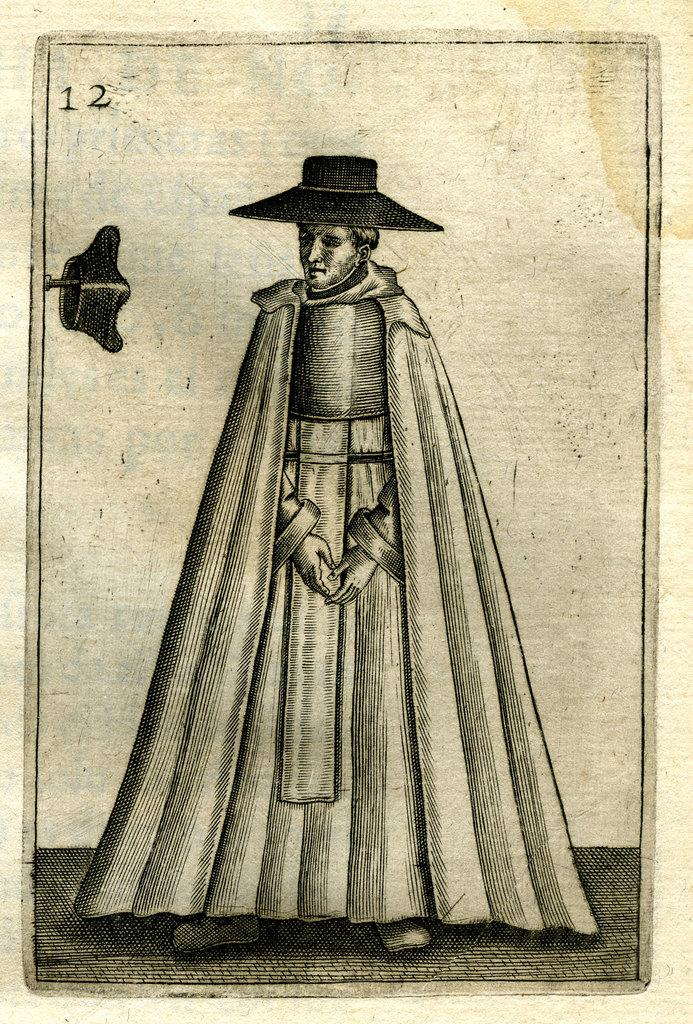What is present in the image? There is a poster in the image. What is depicted on the poster? There is a man in the center of the poster. What is the man wearing? The man is wearing a hat and a dress. Where is another hat located in the image? The second hat is kept on a needle. What type of roof can be seen on the beetle in the image? There is no beetle present in the image, and therefore no roof can be seen on it. How does the toothpaste contribute to the man's outfit in the image? There is no toothpaste mentioned or visible in the image, so it does not contribute to the man's outfit. 